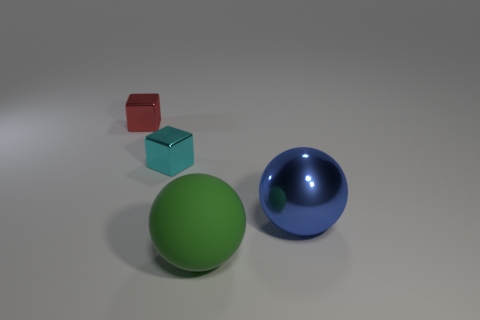Subtract all red blocks. How many blocks are left? 1 Add 1 large green shiny cylinders. How many objects exist? 5 Subtract all yellow blocks. How many red balls are left? 0 Subtract all cyan metal blocks. Subtract all shiny objects. How many objects are left? 0 Add 1 metallic balls. How many metallic balls are left? 2 Add 1 big matte objects. How many big matte objects exist? 2 Subtract 0 blue cylinders. How many objects are left? 4 Subtract all blue spheres. Subtract all cyan cylinders. How many spheres are left? 1 